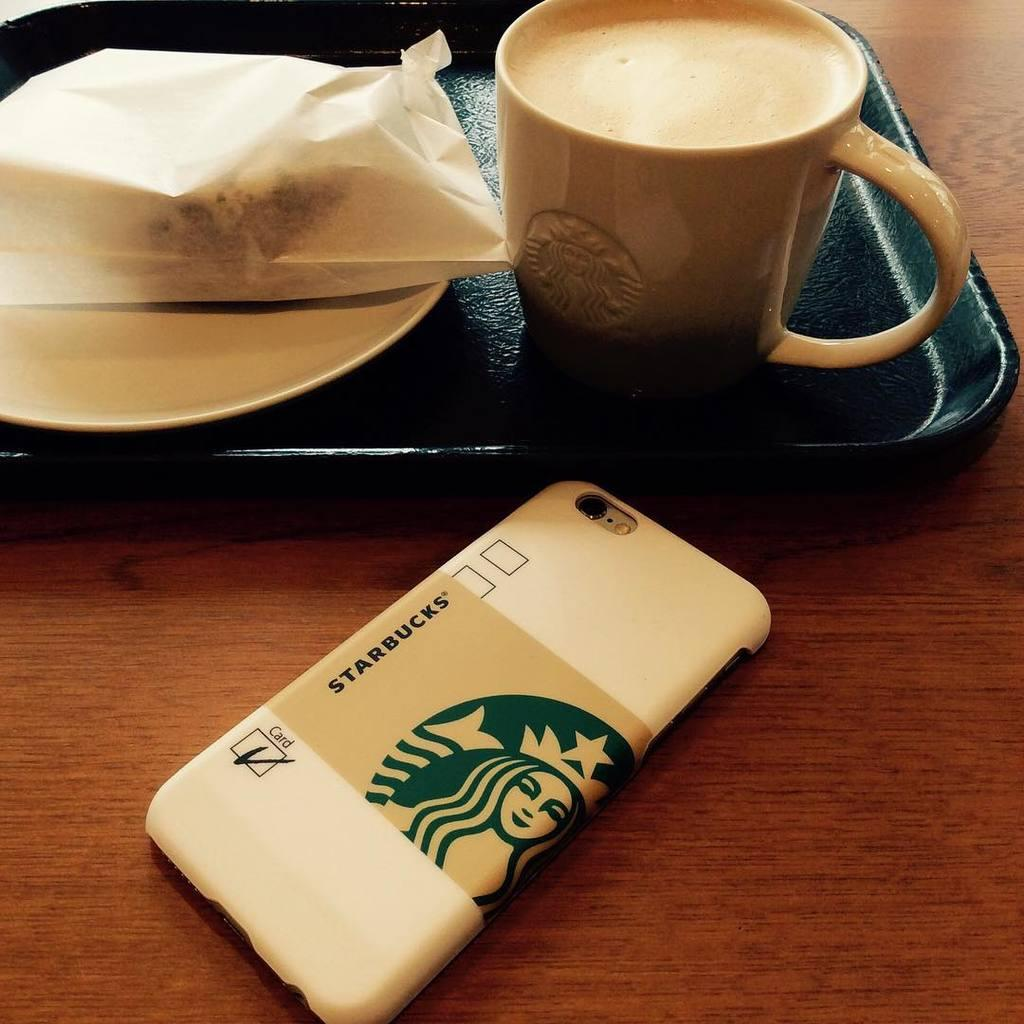<image>
Render a clear and concise summary of the photo. a Starbucks cellphone case in front of a tray of coffee and a treat 